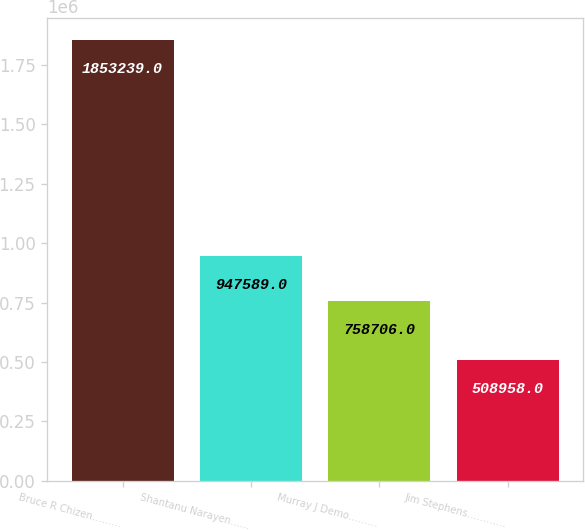Convert chart. <chart><loc_0><loc_0><loc_500><loc_500><bar_chart><fcel>Bruce R Chizen………<fcel>Shantanu Narayen……<fcel>Murray J Demo………<fcel>Jim Stephens…………<nl><fcel>1.85324e+06<fcel>947589<fcel>758706<fcel>508958<nl></chart> 